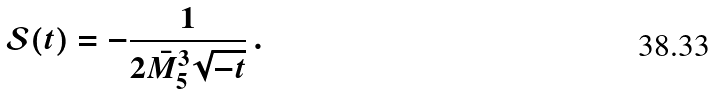Convert formula to latex. <formula><loc_0><loc_0><loc_500><loc_500>\mathcal { S } ( t ) = - \frac { 1 } { 2 \bar { M } _ { 5 } ^ { 3 } \sqrt { - t } } \, .</formula> 